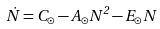Convert formula to latex. <formula><loc_0><loc_0><loc_500><loc_500>\dot { N } = C _ { \odot } - A _ { \odot } N ^ { 2 } - E _ { \odot } N</formula> 